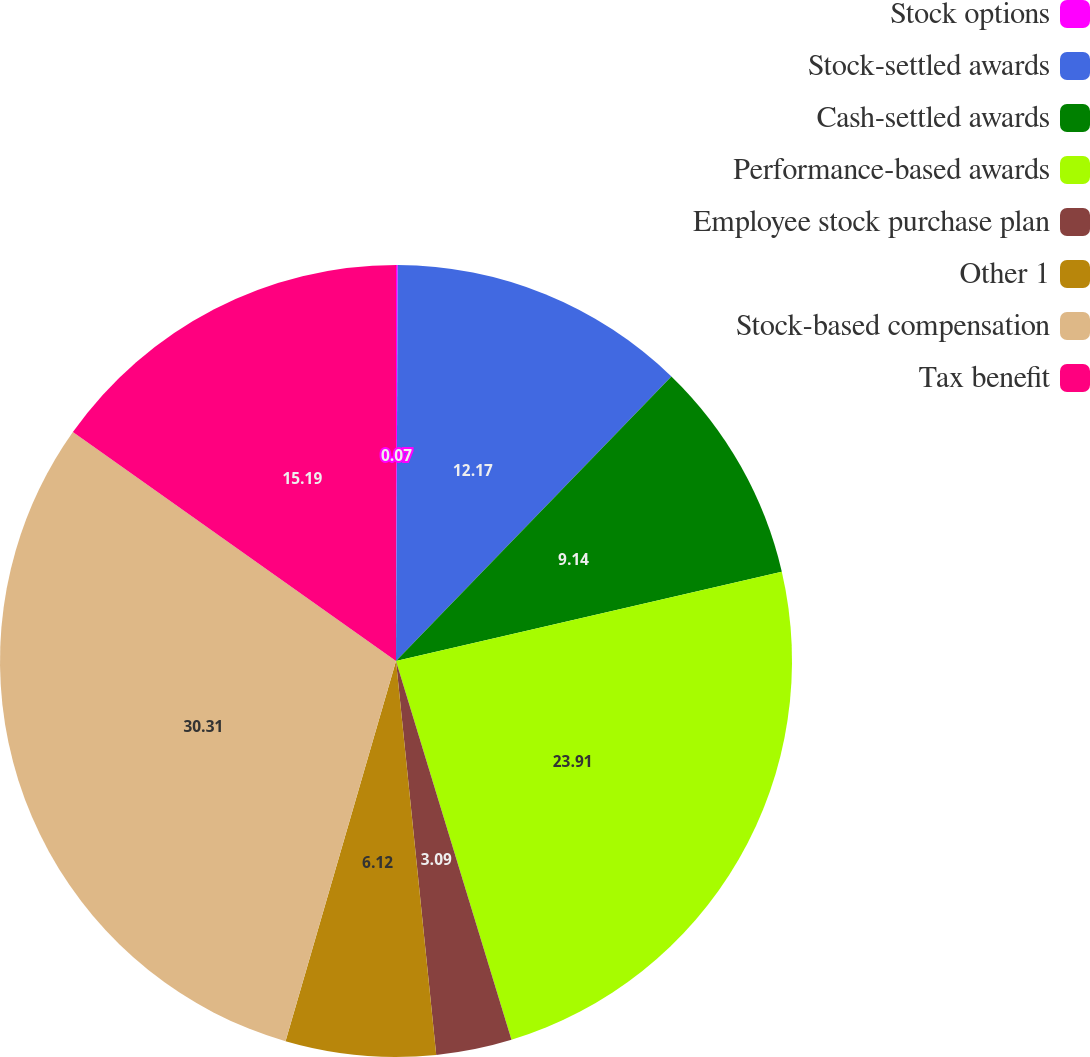Convert chart. <chart><loc_0><loc_0><loc_500><loc_500><pie_chart><fcel>Stock options<fcel>Stock-settled awards<fcel>Cash-settled awards<fcel>Performance-based awards<fcel>Employee stock purchase plan<fcel>Other 1<fcel>Stock-based compensation<fcel>Tax benefit<nl><fcel>0.07%<fcel>12.17%<fcel>9.14%<fcel>23.91%<fcel>3.09%<fcel>6.12%<fcel>30.31%<fcel>15.19%<nl></chart> 